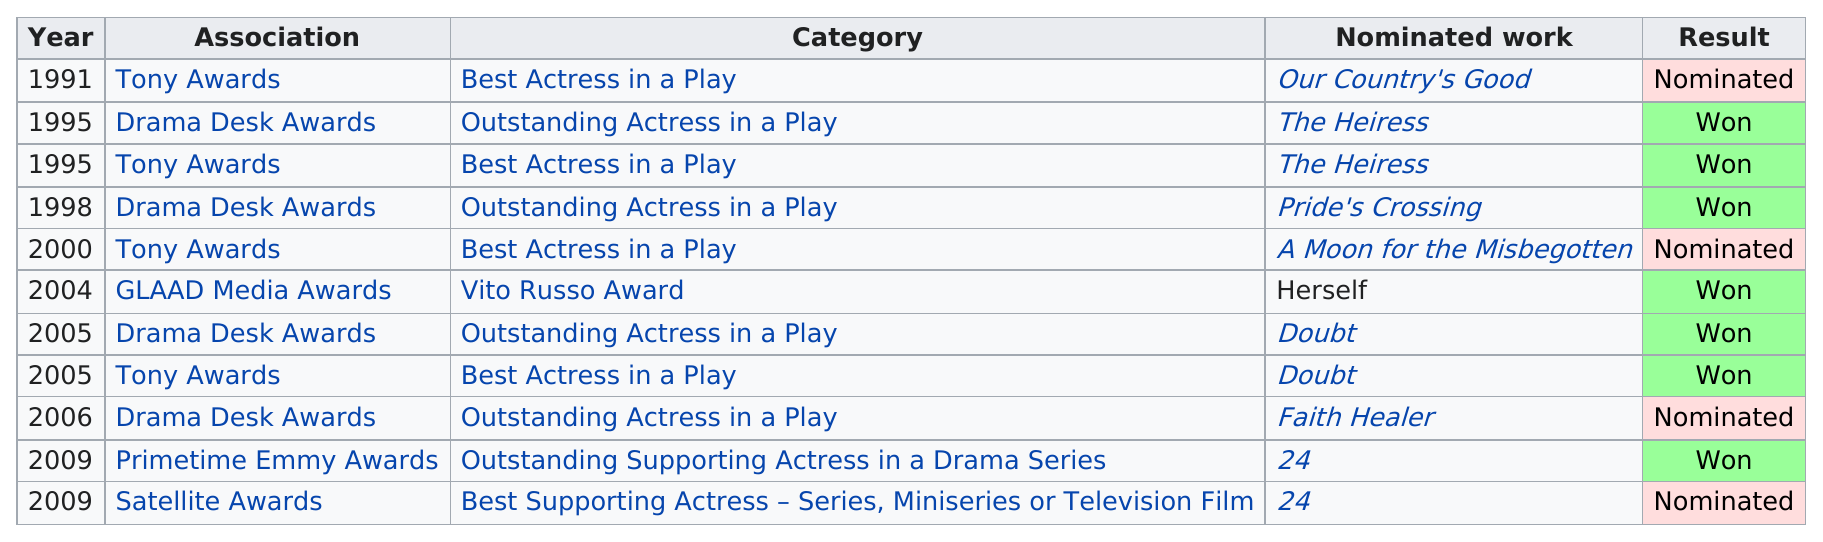Draw attention to some important aspects in this diagram. The subject has been nominated for the 'Best Actress in a Play' award by the Tony Awards a total of four times. The last nomination was for Best Supporting Actress in a series, mini-series, or television film. Jones was awarded his first award in 2000 by the GLAAD Media Awards. In 2005, Jones won the award for Outstanding Actress in a Play, and she also won the award for Best Actress in a Play. The Heiress was the first movie to win. 